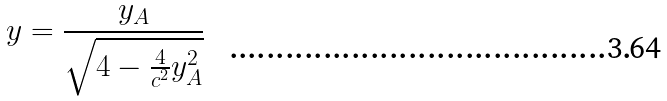Convert formula to latex. <formula><loc_0><loc_0><loc_500><loc_500>y = \frac { y _ { A } } { \sqrt { 4 - \frac { 4 } { c ^ { 2 } } y _ { A } ^ { 2 } } }</formula> 